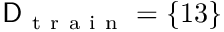Convert formula to latex. <formula><loc_0><loc_0><loc_500><loc_500>D _ { t r a i n } = \{ 1 3 \}</formula> 